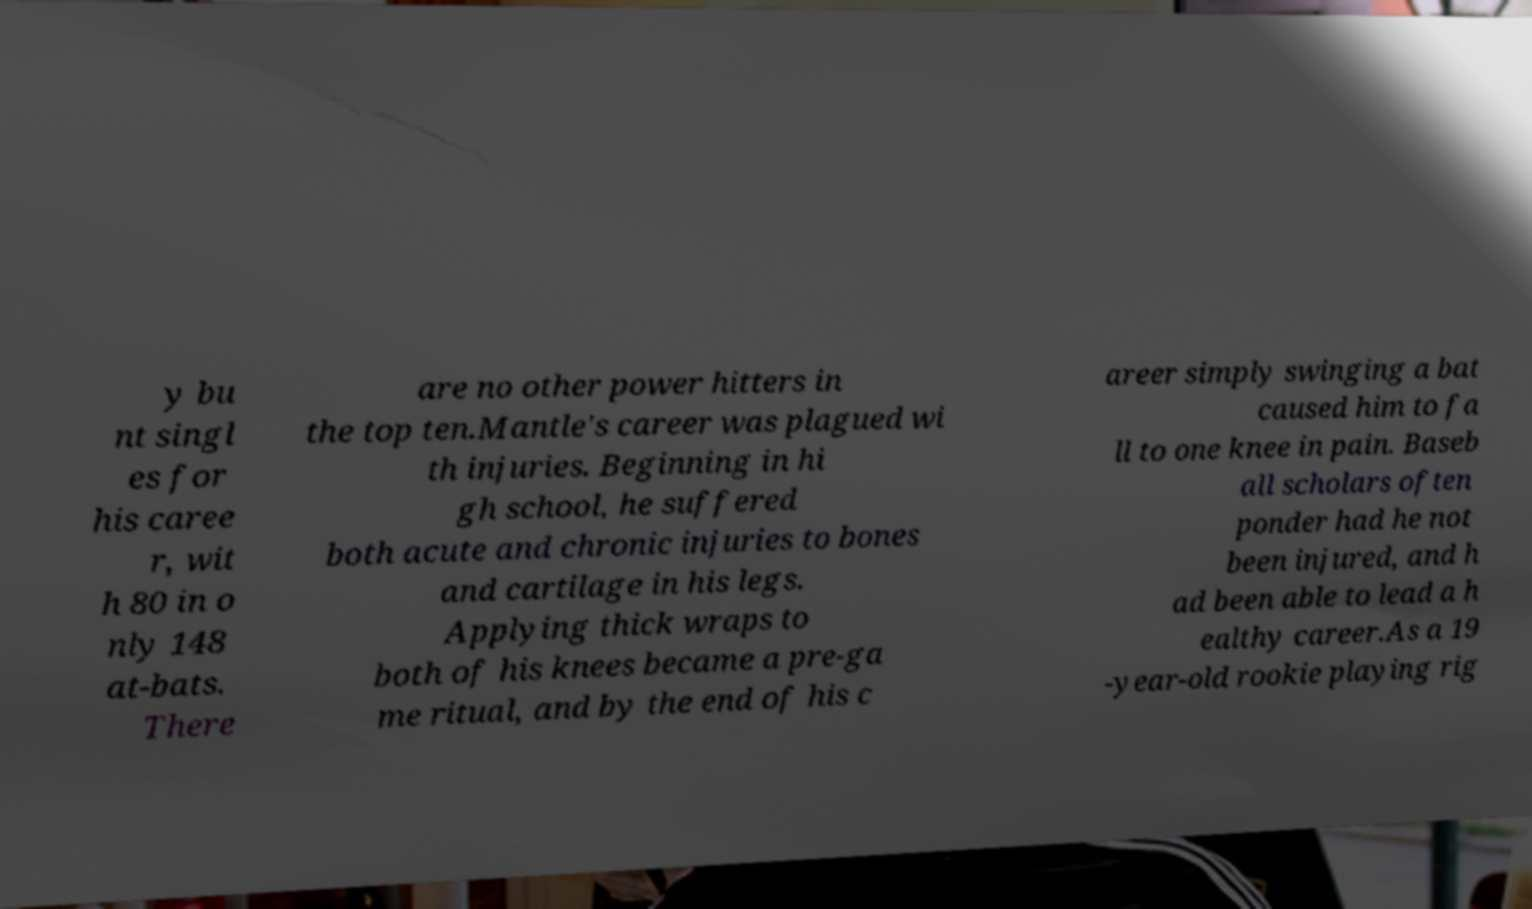There's text embedded in this image that I need extracted. Can you transcribe it verbatim? y bu nt singl es for his caree r, wit h 80 in o nly 148 at-bats. There are no other power hitters in the top ten.Mantle's career was plagued wi th injuries. Beginning in hi gh school, he suffered both acute and chronic injuries to bones and cartilage in his legs. Applying thick wraps to both of his knees became a pre-ga me ritual, and by the end of his c areer simply swinging a bat caused him to fa ll to one knee in pain. Baseb all scholars often ponder had he not been injured, and h ad been able to lead a h ealthy career.As a 19 -year-old rookie playing rig 